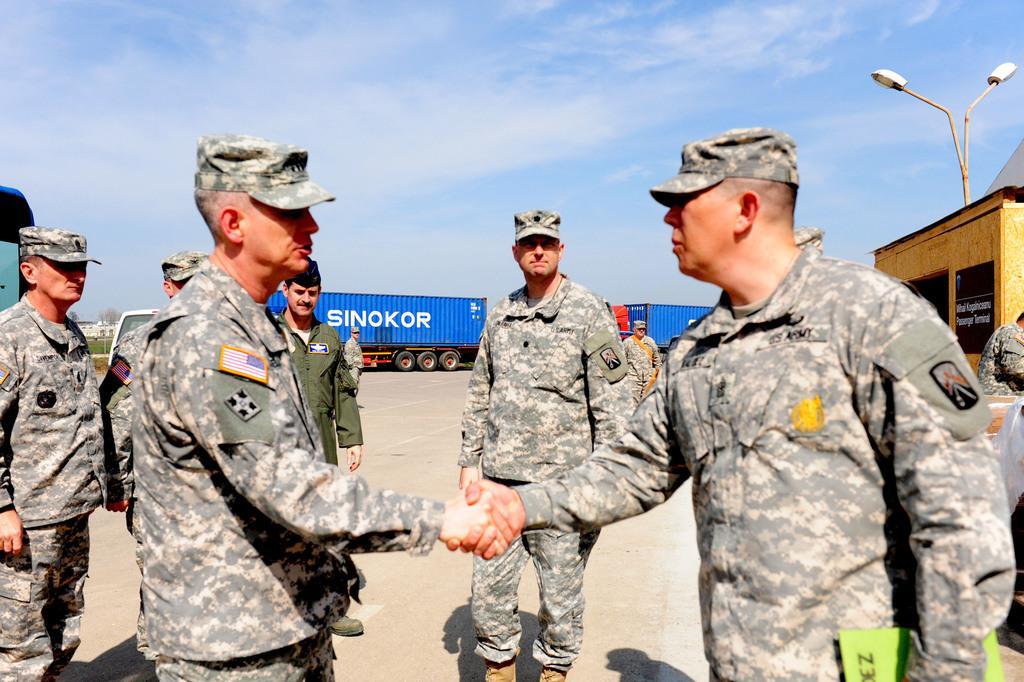Can you describe this image briefly? In this picture we can see a group of people and in the background we can see containers,sky. 